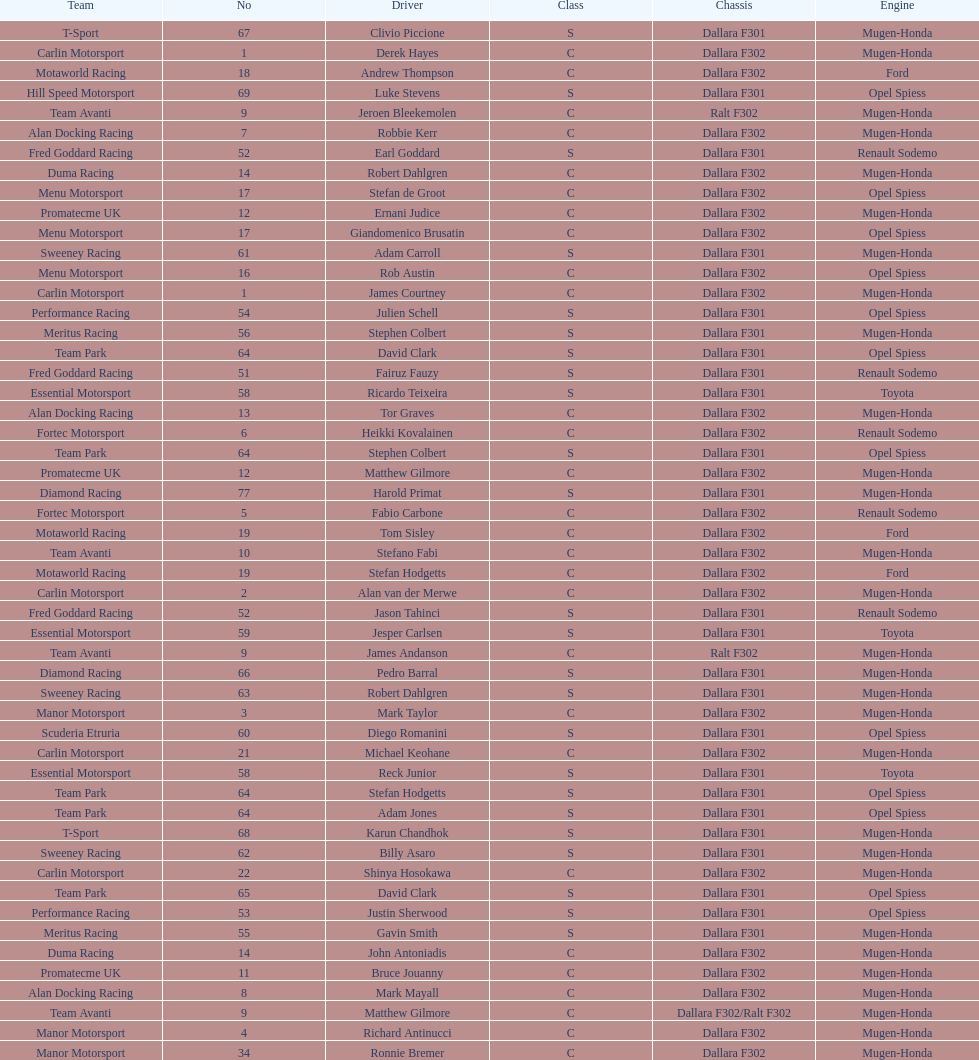How many teams had at least two drivers this season? 17. 